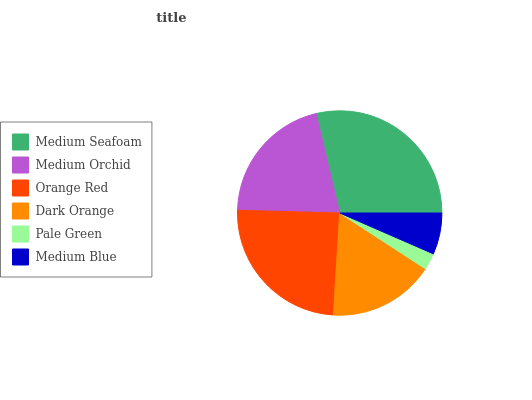Is Pale Green the minimum?
Answer yes or no. Yes. Is Medium Seafoam the maximum?
Answer yes or no. Yes. Is Medium Orchid the minimum?
Answer yes or no. No. Is Medium Orchid the maximum?
Answer yes or no. No. Is Medium Seafoam greater than Medium Orchid?
Answer yes or no. Yes. Is Medium Orchid less than Medium Seafoam?
Answer yes or no. Yes. Is Medium Orchid greater than Medium Seafoam?
Answer yes or no. No. Is Medium Seafoam less than Medium Orchid?
Answer yes or no. No. Is Medium Orchid the high median?
Answer yes or no. Yes. Is Dark Orange the low median?
Answer yes or no. Yes. Is Medium Blue the high median?
Answer yes or no. No. Is Orange Red the low median?
Answer yes or no. No. 